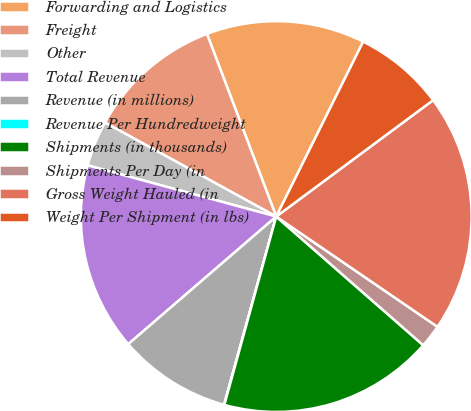<chart> <loc_0><loc_0><loc_500><loc_500><pie_chart><fcel>Forwarding and Logistics<fcel>Freight<fcel>Other<fcel>Total Revenue<fcel>Revenue (in millions)<fcel>Revenue Per Hundredweight<fcel>Shipments (in thousands)<fcel>Shipments Per Day (in<fcel>Gross Weight Hauled (in<fcel>Weight Per Shipment (in lbs)<nl><fcel>13.11%<fcel>11.24%<fcel>3.77%<fcel>15.54%<fcel>9.37%<fcel>0.03%<fcel>17.83%<fcel>1.9%<fcel>19.7%<fcel>7.5%<nl></chart> 